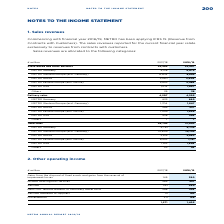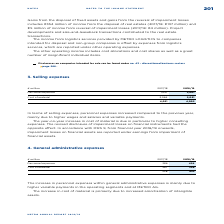According to Metro Ag's financial document, What does the other operating income include? cost allocations and cost shares as well as a great number of insignificant individual items.. The document states: "The other operating income includes cost allocations and cost shares as well as a great number of insignificant individual items...." Also, What is offset by expenses from logistic services? The income from logistics services provided by METRO LOGISTICS to companies intended for disposal and non-group companies. The document states: "The income from logistics services provided by METRO LOGISTICS to companies intended for disposal and non-group companies is offset by expenses from l..." Also, What are the components of Gains from the disposal of fixed assets and gains from the reversal of impairment losses? The document shows two values: income from the disposal of real estates and income from reversal of impairment losses. From the document: "€5 million of income from reversal of impairment losses (2017/18: €4 million). Project includes €354 million of income from the disposal of real estat..." Additionally, In which year was the amount of Services larger? Based on the financial document, the answer is 2017/2018. Also, can you calculate: What was the change in Miscellaneous in 2018/2019 from 2017/2018? Based on the calculation: 198-211, the result is -13 (in millions). This is based on the information: "Miscellaneous 211 198 Miscellaneous 211 198..." The key data points involved are: 198, 211. Also, can you calculate: What was the percentage change in Miscellaneous in  2018/2019 from 2017/2018? To answer this question, I need to perform calculations using the financial data. The calculation is: (198-211)/211, which equals -6.16 (percentage). This is based on the information: "Miscellaneous 211 198 Miscellaneous 211 198..." The key data points involved are: 198, 211. 